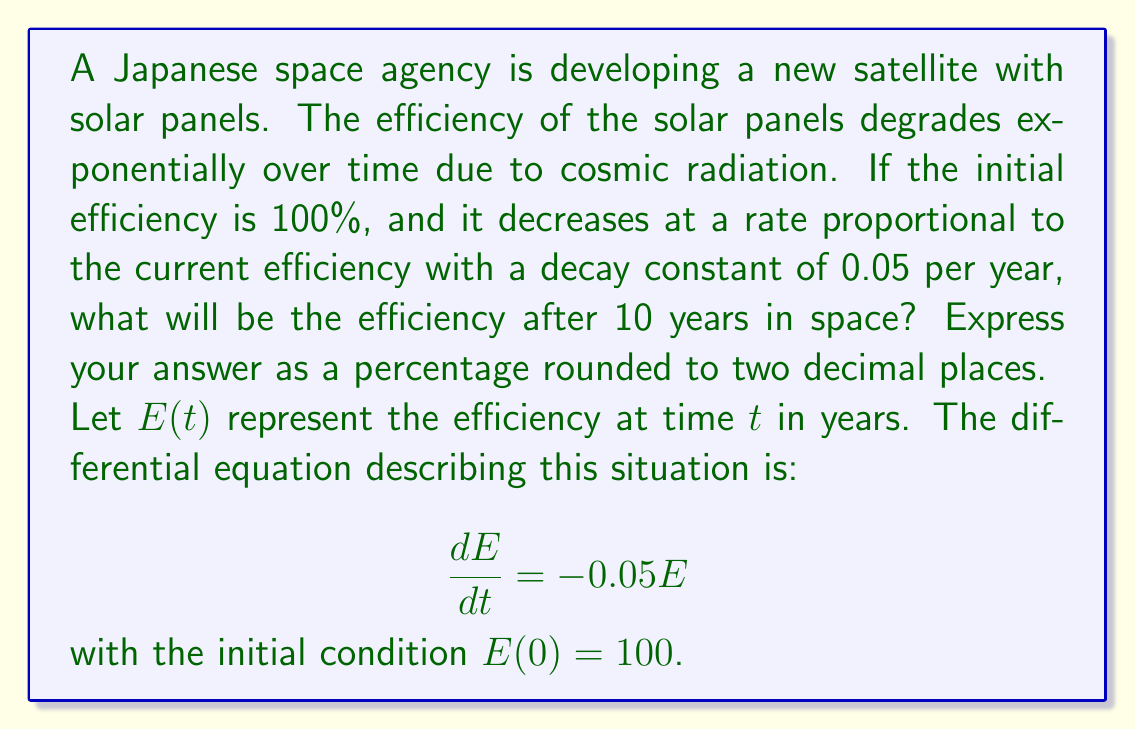Solve this math problem. To solve this first-order differential equation, we can use the following steps:

1) The general solution for this type of differential equation is:

   $E(t) = Ce^{-0.05t}$

   where $C$ is a constant we need to determine.

2) Using the initial condition $E(0) = 100$, we can find $C$:

   $100 = Ce^{-0.05(0)}$
   $100 = C$

3) Therefore, the specific solution is:

   $E(t) = 100e^{-0.05t}$

4) To find the efficiency after 10 years, we substitute $t = 10$:

   $E(10) = 100e^{-0.05(10)}$
   $E(10) = 100e^{-0.5}$

5) Calculate this value:

   $E(10) = 100 \cdot 0.6065306597126334$
   $E(10) \approx 60.65306597126334$

6) Rounding to two decimal places:

   $E(10) \approx 60.65\%$
Answer: 60.65% 